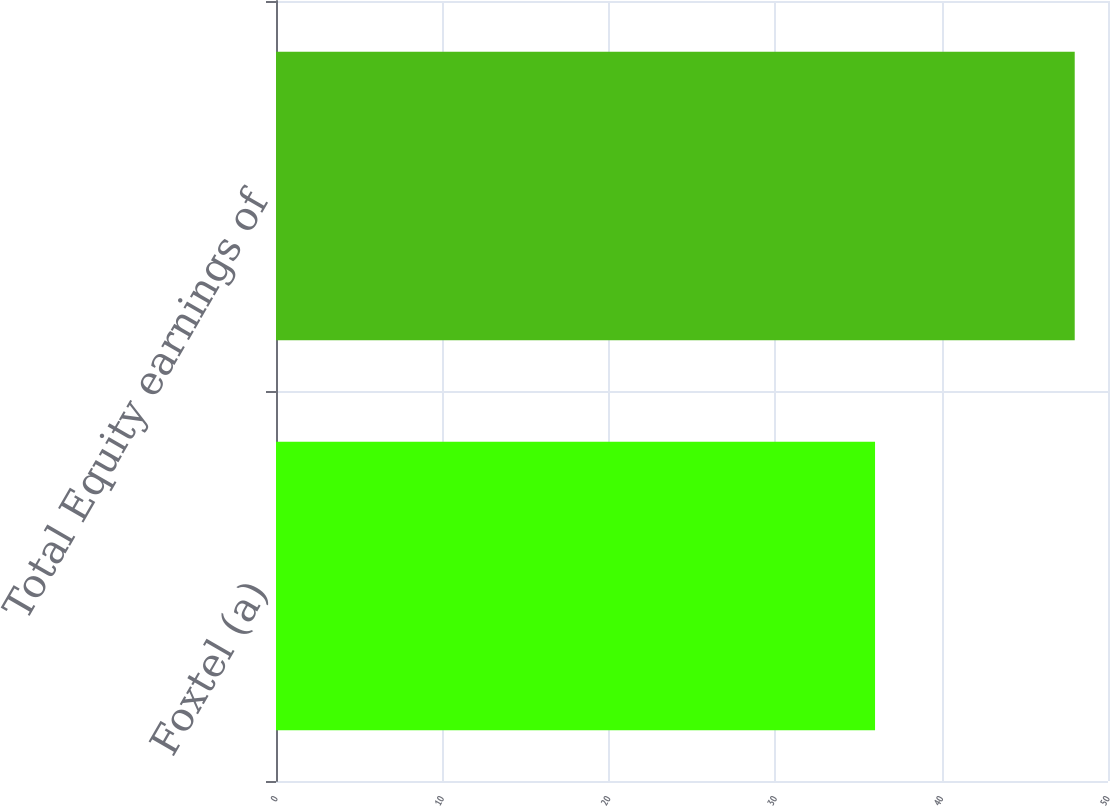Convert chart to OTSL. <chart><loc_0><loc_0><loc_500><loc_500><bar_chart><fcel>Foxtel (a)<fcel>Total Equity earnings of<nl><fcel>36<fcel>48<nl></chart> 